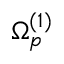<formula> <loc_0><loc_0><loc_500><loc_500>\Omega _ { p } ^ { ( 1 ) }</formula> 